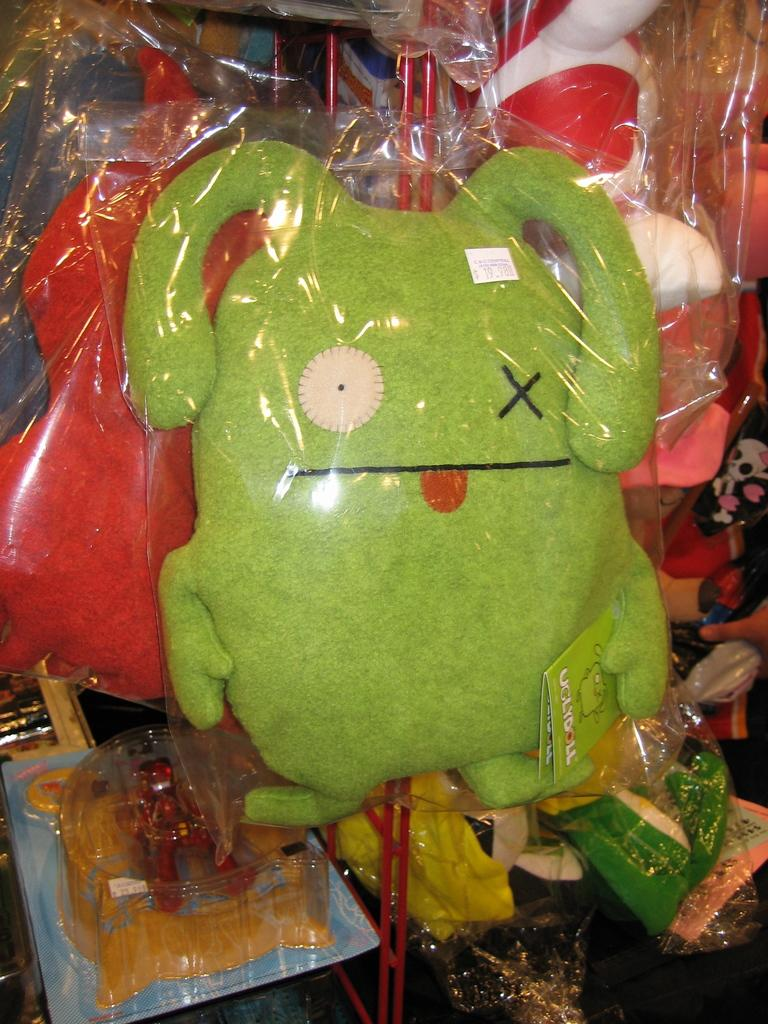What objects are present in the image? There are toys in the image. How are the toys protected or stored? The toys are in plastic covers. What colors can be seen among the toys? There are green and red color toys visible. What type of chess pieces can be seen in the image? There is no chess set present in the image; it features toys in plastic covers. What channel is the ship sailing on in the image? There is no ship present in the image, so it is not possible to determine which channel it might be sailing on. 